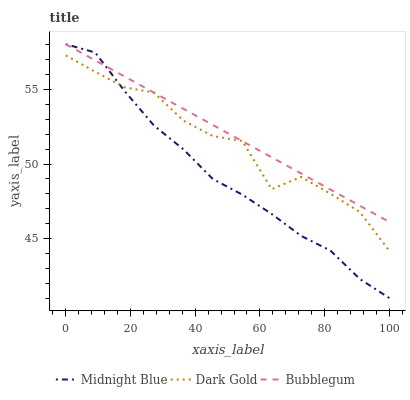Does Midnight Blue have the minimum area under the curve?
Answer yes or no. Yes. Does Bubblegum have the maximum area under the curve?
Answer yes or no. Yes. Does Dark Gold have the minimum area under the curve?
Answer yes or no. No. Does Dark Gold have the maximum area under the curve?
Answer yes or no. No. Is Bubblegum the smoothest?
Answer yes or no. Yes. Is Dark Gold the roughest?
Answer yes or no. Yes. Is Dark Gold the smoothest?
Answer yes or no. No. Is Bubblegum the roughest?
Answer yes or no. No. Does Midnight Blue have the lowest value?
Answer yes or no. Yes. Does Dark Gold have the lowest value?
Answer yes or no. No. Does Bubblegum have the highest value?
Answer yes or no. Yes. Does Dark Gold have the highest value?
Answer yes or no. No. Does Dark Gold intersect Bubblegum?
Answer yes or no. Yes. Is Dark Gold less than Bubblegum?
Answer yes or no. No. Is Dark Gold greater than Bubblegum?
Answer yes or no. No. 